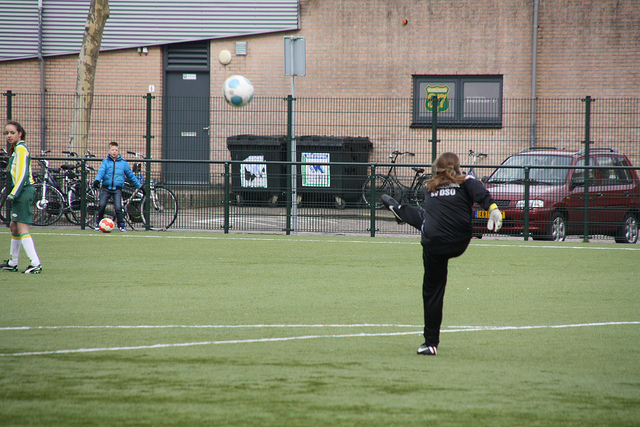Identify and read out the text in this image. OSO 